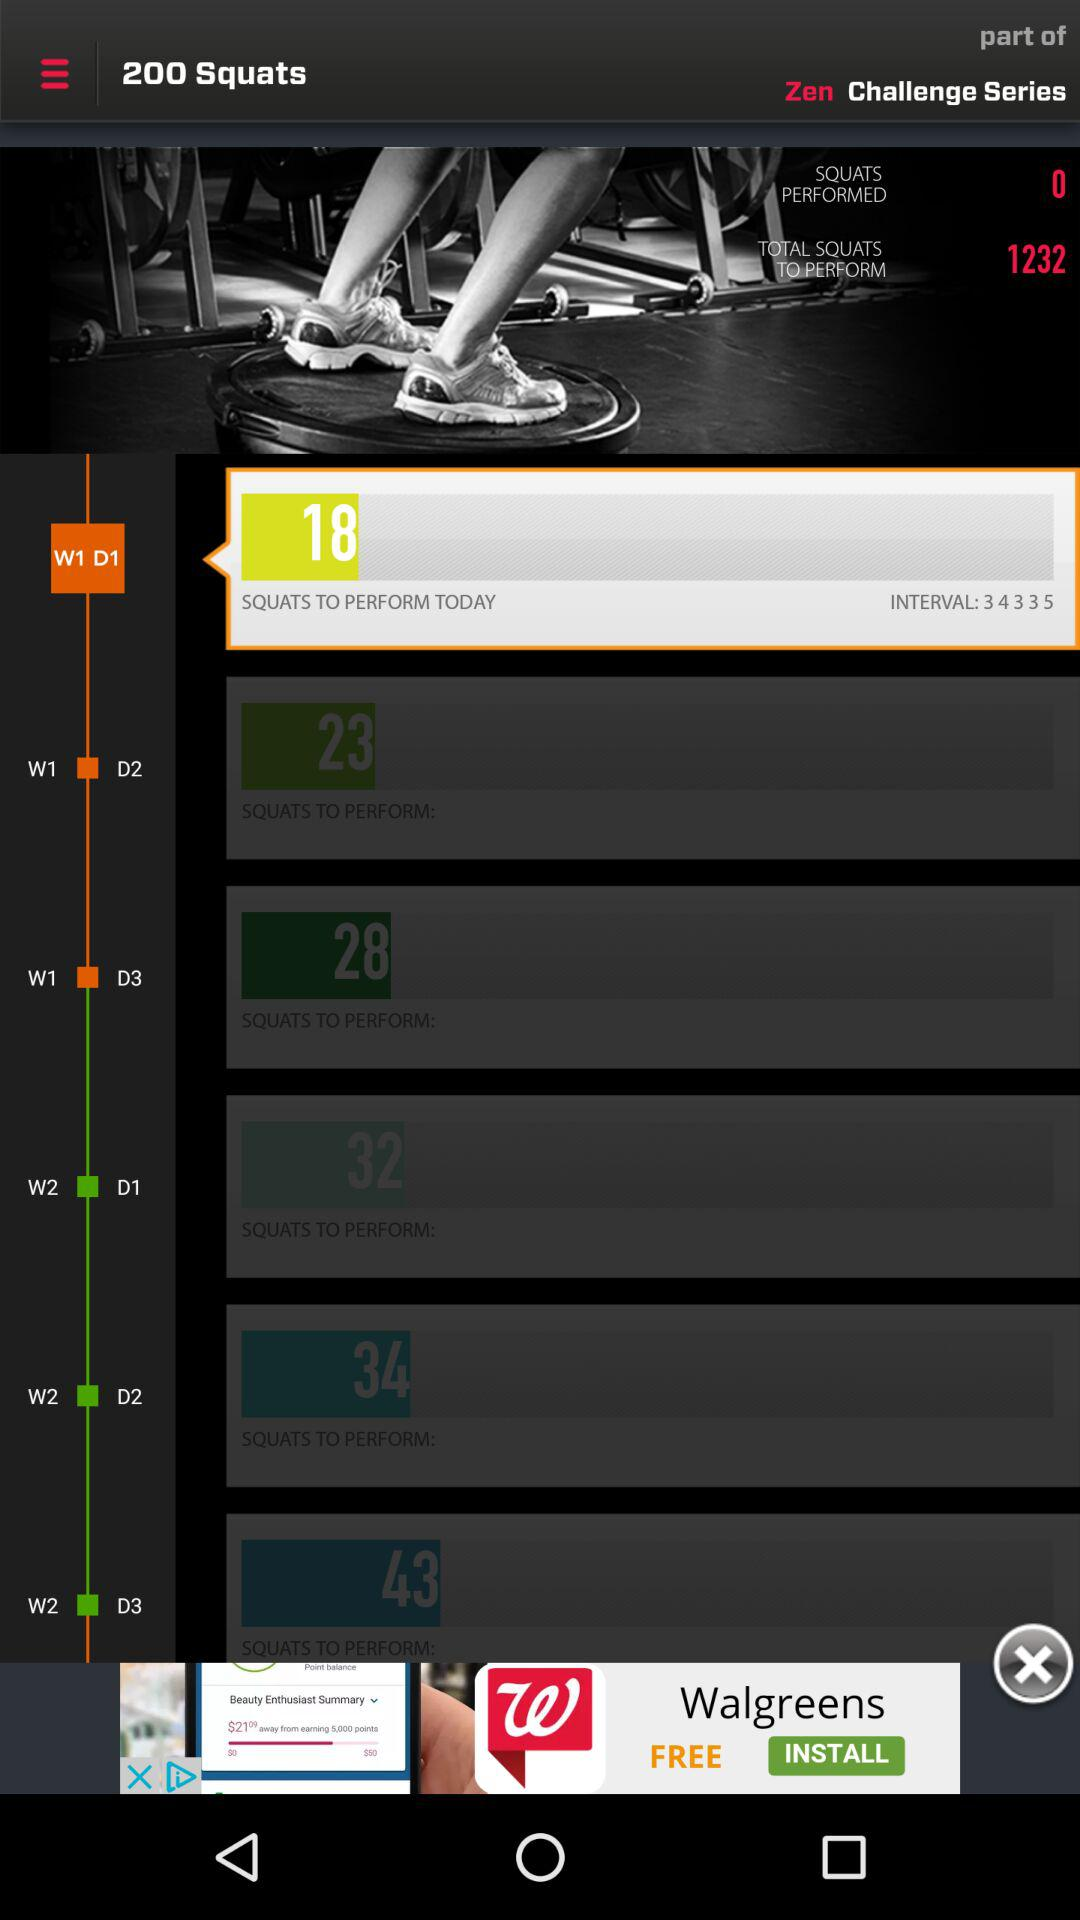How many squats in total are to be performed on Day 2 of Week 2? The number of squats that are to be performed on Day 2 of Week 2 is 34. 